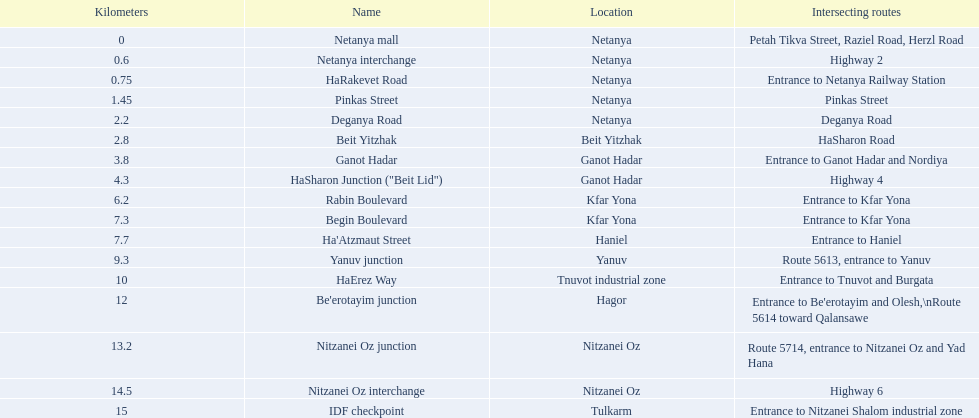After kfar yona, which location is next? Haniel. 